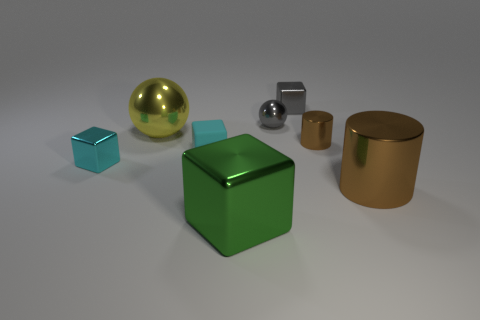The tiny thing on the right side of the metallic block right of the object that is in front of the large brown cylinder is what color?
Provide a short and direct response. Brown. What number of things are in front of the small cyan rubber object and to the right of the green metallic cube?
Offer a terse response. 1. Do the large metal block left of the small gray cube and the metallic cube to the left of the big green thing have the same color?
Make the answer very short. No. Is there anything else that is made of the same material as the small gray cube?
Your answer should be very brief. Yes. The green object that is the same shape as the tiny cyan matte object is what size?
Make the answer very short. Large. There is a cyan shiny object; are there any cylinders left of it?
Keep it short and to the point. No. Are there the same number of tiny metallic spheres in front of the matte cube and big cubes?
Make the answer very short. No. There is a big brown object that is in front of the large metal ball that is behind the large green object; are there any tiny metallic objects that are on the right side of it?
Ensure brevity in your answer.  No. What is the material of the green object?
Give a very brief answer. Metal. How many other objects are the same shape as the large green thing?
Provide a succinct answer. 3. 